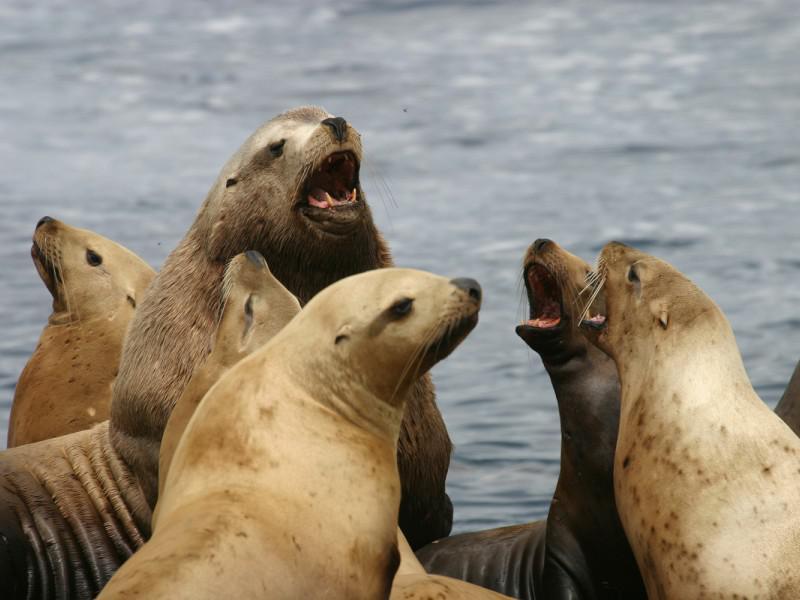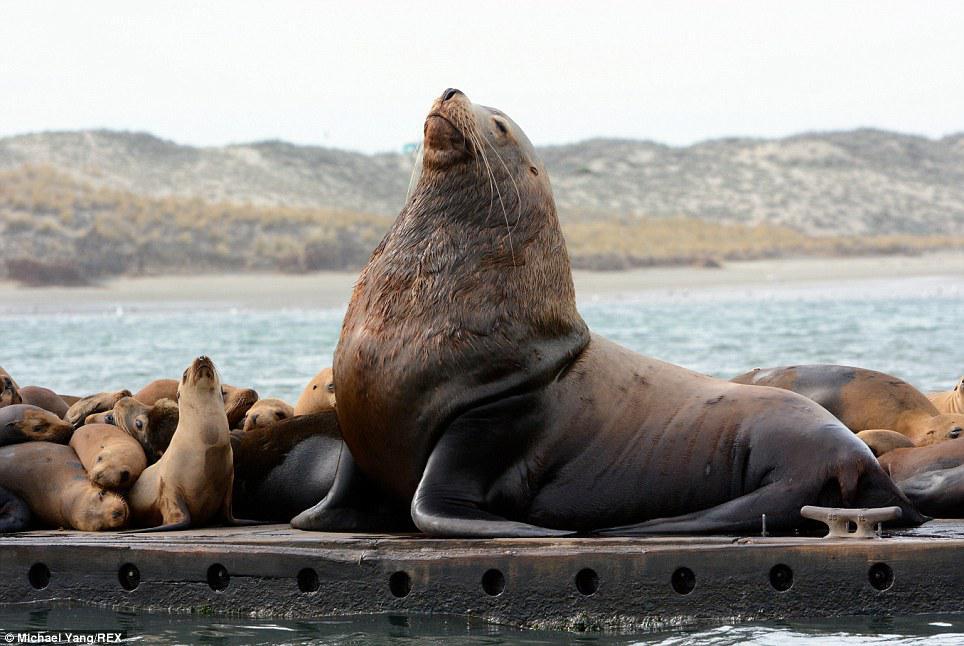The first image is the image on the left, the second image is the image on the right. Given the left and right images, does the statement "The left image contains no more than one seal." hold true? Answer yes or no. No. The first image is the image on the left, the second image is the image on the right. Examine the images to the left and right. Is the description "A single seal is on the beach in the image on the left." accurate? Answer yes or no. No. 